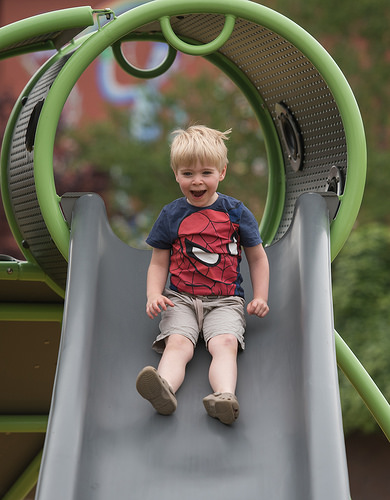<image>
Is the shoe under the slide? No. The shoe is not positioned under the slide. The vertical relationship between these objects is different. Is the child to the right of the slide? No. The child is not to the right of the slide. The horizontal positioning shows a different relationship. Is the handle above the slide? Yes. The handle is positioned above the slide in the vertical space, higher up in the scene. 